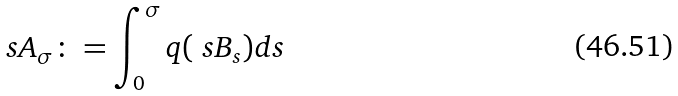<formula> <loc_0><loc_0><loc_500><loc_500>\ s A _ { \sigma } \colon = \int _ { 0 } ^ { \sigma } q ( \ s B _ { s } ) d s \,</formula> 